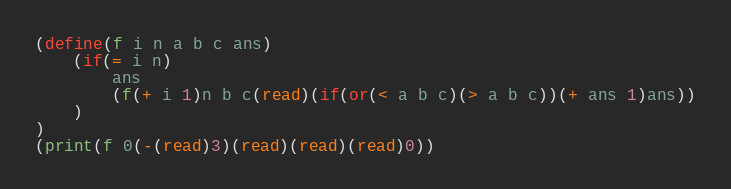Convert code to text. <code><loc_0><loc_0><loc_500><loc_500><_Scheme_>(define(f i n a b c ans)
	(if(= i n)
		ans
		(f(+ i 1)n b c(read)(if(or(< a b c)(> a b c))(+ ans 1)ans))
	)
)
(print(f 0(-(read)3)(read)(read)(read)0))</code> 